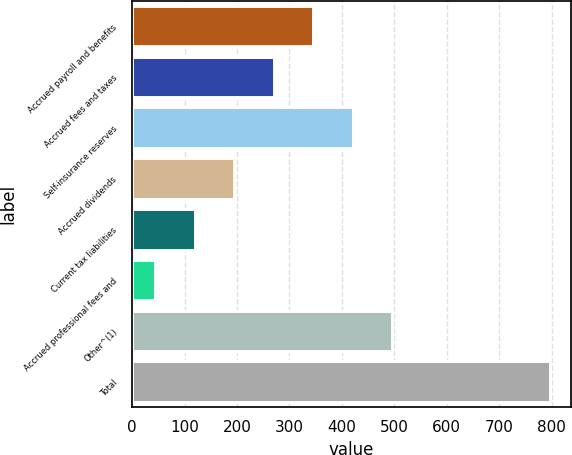Convert chart. <chart><loc_0><loc_0><loc_500><loc_500><bar_chart><fcel>Accrued payroll and benefits<fcel>Accrued fees and taxes<fcel>Self-insurance reserves<fcel>Accrued dividends<fcel>Current tax liabilities<fcel>Accrued professional fees and<fcel>Other^(1)<fcel>Total<nl><fcel>344.94<fcel>269.63<fcel>420.25<fcel>194.32<fcel>119.01<fcel>43.7<fcel>495.56<fcel>796.8<nl></chart> 